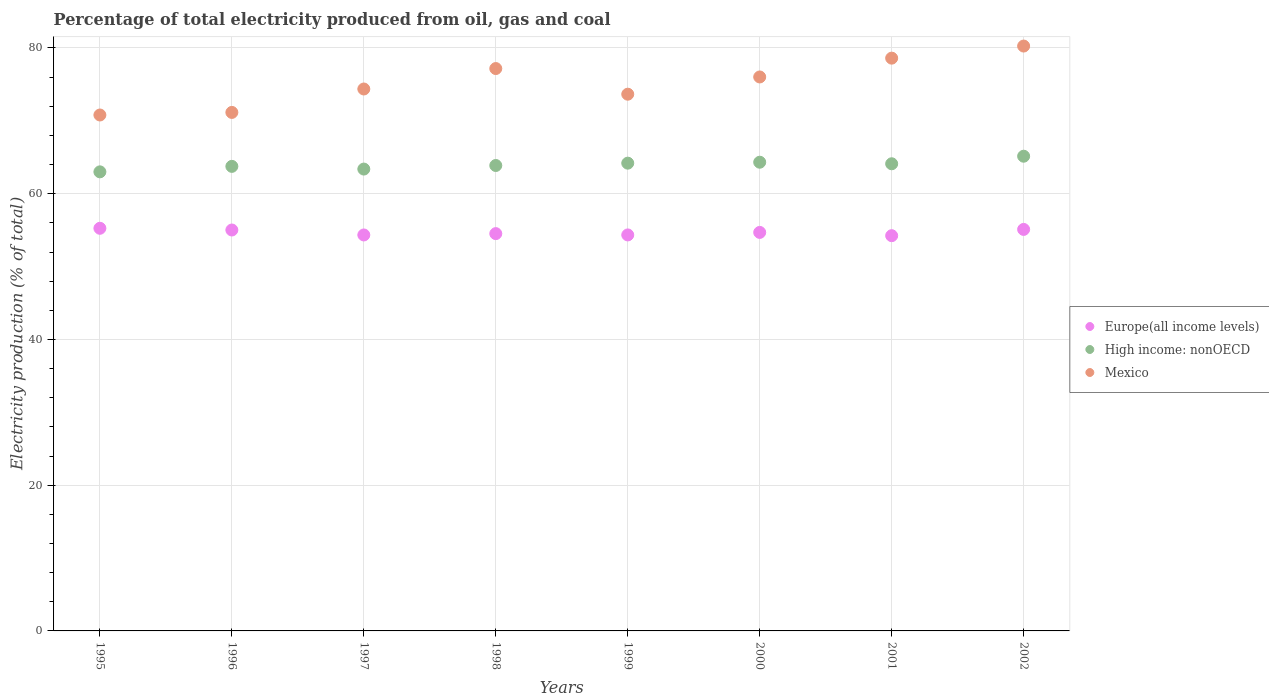How many different coloured dotlines are there?
Keep it short and to the point. 3. What is the electricity production in in Europe(all income levels) in 1995?
Your answer should be very brief. 55.26. Across all years, what is the maximum electricity production in in Europe(all income levels)?
Your answer should be compact. 55.26. Across all years, what is the minimum electricity production in in Mexico?
Your response must be concise. 70.8. In which year was the electricity production in in High income: nonOECD minimum?
Make the answer very short. 1995. What is the total electricity production in in Mexico in the graph?
Your answer should be very brief. 602.07. What is the difference between the electricity production in in Mexico in 1995 and that in 1997?
Offer a terse response. -3.57. What is the difference between the electricity production in in Mexico in 2001 and the electricity production in in High income: nonOECD in 2000?
Make the answer very short. 14.28. What is the average electricity production in in Europe(all income levels) per year?
Keep it short and to the point. 54.69. In the year 2002, what is the difference between the electricity production in in High income: nonOECD and electricity production in in Mexico?
Keep it short and to the point. -15.12. What is the ratio of the electricity production in in Mexico in 1998 to that in 2002?
Offer a very short reply. 0.96. Is the electricity production in in Mexico in 1997 less than that in 1999?
Offer a very short reply. No. What is the difference between the highest and the second highest electricity production in in High income: nonOECD?
Your answer should be very brief. 0.82. What is the difference between the highest and the lowest electricity production in in Mexico?
Offer a very short reply. 9.46. In how many years, is the electricity production in in Mexico greater than the average electricity production in in Mexico taken over all years?
Offer a terse response. 4. Is the sum of the electricity production in in High income: nonOECD in 2000 and 2001 greater than the maximum electricity production in in Mexico across all years?
Your answer should be very brief. Yes. Does the electricity production in in Mexico monotonically increase over the years?
Your response must be concise. No. Is the electricity production in in High income: nonOECD strictly greater than the electricity production in in Europe(all income levels) over the years?
Give a very brief answer. Yes. How many dotlines are there?
Offer a very short reply. 3. How many years are there in the graph?
Provide a succinct answer. 8. What is the difference between two consecutive major ticks on the Y-axis?
Offer a very short reply. 20. Are the values on the major ticks of Y-axis written in scientific E-notation?
Ensure brevity in your answer.  No. Does the graph contain any zero values?
Make the answer very short. No. Does the graph contain grids?
Offer a very short reply. Yes. How are the legend labels stacked?
Give a very brief answer. Vertical. What is the title of the graph?
Keep it short and to the point. Percentage of total electricity produced from oil, gas and coal. Does "Lao PDR" appear as one of the legend labels in the graph?
Offer a terse response. No. What is the label or title of the X-axis?
Ensure brevity in your answer.  Years. What is the label or title of the Y-axis?
Your answer should be compact. Electricity production (% of total). What is the Electricity production (% of total) of Europe(all income levels) in 1995?
Provide a succinct answer. 55.26. What is the Electricity production (% of total) of High income: nonOECD in 1995?
Provide a short and direct response. 63. What is the Electricity production (% of total) of Mexico in 1995?
Give a very brief answer. 70.8. What is the Electricity production (% of total) of Europe(all income levels) in 1996?
Make the answer very short. 55.02. What is the Electricity production (% of total) of High income: nonOECD in 1996?
Make the answer very short. 63.75. What is the Electricity production (% of total) in Mexico in 1996?
Give a very brief answer. 71.16. What is the Electricity production (% of total) in Europe(all income levels) in 1997?
Your answer should be very brief. 54.34. What is the Electricity production (% of total) of High income: nonOECD in 1997?
Your answer should be very brief. 63.38. What is the Electricity production (% of total) in Mexico in 1997?
Offer a very short reply. 74.37. What is the Electricity production (% of total) of Europe(all income levels) in 1998?
Provide a succinct answer. 54.53. What is the Electricity production (% of total) of High income: nonOECD in 1998?
Offer a terse response. 63.87. What is the Electricity production (% of total) of Mexico in 1998?
Give a very brief answer. 77.18. What is the Electricity production (% of total) in Europe(all income levels) in 1999?
Your answer should be compact. 54.34. What is the Electricity production (% of total) in High income: nonOECD in 1999?
Give a very brief answer. 64.2. What is the Electricity production (% of total) in Mexico in 1999?
Provide a succinct answer. 73.66. What is the Electricity production (% of total) of Europe(all income levels) in 2000?
Your response must be concise. 54.69. What is the Electricity production (% of total) of High income: nonOECD in 2000?
Give a very brief answer. 64.32. What is the Electricity production (% of total) of Mexico in 2000?
Offer a very short reply. 76.02. What is the Electricity production (% of total) of Europe(all income levels) in 2001?
Make the answer very short. 54.24. What is the Electricity production (% of total) of High income: nonOECD in 2001?
Your response must be concise. 64.11. What is the Electricity production (% of total) in Mexico in 2001?
Ensure brevity in your answer.  78.61. What is the Electricity production (% of total) of Europe(all income levels) in 2002?
Your answer should be compact. 55.1. What is the Electricity production (% of total) of High income: nonOECD in 2002?
Your response must be concise. 65.15. What is the Electricity production (% of total) in Mexico in 2002?
Provide a succinct answer. 80.27. Across all years, what is the maximum Electricity production (% of total) in Europe(all income levels)?
Offer a terse response. 55.26. Across all years, what is the maximum Electricity production (% of total) in High income: nonOECD?
Offer a very short reply. 65.15. Across all years, what is the maximum Electricity production (% of total) of Mexico?
Give a very brief answer. 80.27. Across all years, what is the minimum Electricity production (% of total) in Europe(all income levels)?
Make the answer very short. 54.24. Across all years, what is the minimum Electricity production (% of total) in High income: nonOECD?
Provide a succinct answer. 63. Across all years, what is the minimum Electricity production (% of total) in Mexico?
Your answer should be compact. 70.8. What is the total Electricity production (% of total) of Europe(all income levels) in the graph?
Your answer should be very brief. 437.52. What is the total Electricity production (% of total) of High income: nonOECD in the graph?
Your response must be concise. 511.79. What is the total Electricity production (% of total) in Mexico in the graph?
Offer a very short reply. 602.07. What is the difference between the Electricity production (% of total) in Europe(all income levels) in 1995 and that in 1996?
Make the answer very short. 0.24. What is the difference between the Electricity production (% of total) of High income: nonOECD in 1995 and that in 1996?
Your response must be concise. -0.75. What is the difference between the Electricity production (% of total) in Mexico in 1995 and that in 1996?
Your answer should be compact. -0.35. What is the difference between the Electricity production (% of total) of Europe(all income levels) in 1995 and that in 1997?
Give a very brief answer. 0.92. What is the difference between the Electricity production (% of total) in High income: nonOECD in 1995 and that in 1997?
Offer a very short reply. -0.38. What is the difference between the Electricity production (% of total) in Mexico in 1995 and that in 1997?
Make the answer very short. -3.57. What is the difference between the Electricity production (% of total) of Europe(all income levels) in 1995 and that in 1998?
Provide a succinct answer. 0.73. What is the difference between the Electricity production (% of total) in High income: nonOECD in 1995 and that in 1998?
Offer a very short reply. -0.87. What is the difference between the Electricity production (% of total) of Mexico in 1995 and that in 1998?
Your response must be concise. -6.37. What is the difference between the Electricity production (% of total) of Europe(all income levels) in 1995 and that in 1999?
Provide a succinct answer. 0.91. What is the difference between the Electricity production (% of total) of High income: nonOECD in 1995 and that in 1999?
Offer a terse response. -1.19. What is the difference between the Electricity production (% of total) in Mexico in 1995 and that in 1999?
Offer a very short reply. -2.85. What is the difference between the Electricity production (% of total) in Europe(all income levels) in 1995 and that in 2000?
Offer a terse response. 0.57. What is the difference between the Electricity production (% of total) in High income: nonOECD in 1995 and that in 2000?
Offer a very short reply. -1.32. What is the difference between the Electricity production (% of total) of Mexico in 1995 and that in 2000?
Your answer should be very brief. -5.22. What is the difference between the Electricity production (% of total) in Europe(all income levels) in 1995 and that in 2001?
Your answer should be compact. 1.02. What is the difference between the Electricity production (% of total) in High income: nonOECD in 1995 and that in 2001?
Keep it short and to the point. -1.11. What is the difference between the Electricity production (% of total) in Mexico in 1995 and that in 2001?
Your answer should be very brief. -7.8. What is the difference between the Electricity production (% of total) in Europe(all income levels) in 1995 and that in 2002?
Provide a succinct answer. 0.15. What is the difference between the Electricity production (% of total) in High income: nonOECD in 1995 and that in 2002?
Give a very brief answer. -2.14. What is the difference between the Electricity production (% of total) in Mexico in 1995 and that in 2002?
Keep it short and to the point. -9.46. What is the difference between the Electricity production (% of total) of Europe(all income levels) in 1996 and that in 1997?
Your answer should be compact. 0.68. What is the difference between the Electricity production (% of total) in High income: nonOECD in 1996 and that in 1997?
Your answer should be compact. 0.37. What is the difference between the Electricity production (% of total) of Mexico in 1996 and that in 1997?
Your answer should be very brief. -3.21. What is the difference between the Electricity production (% of total) of Europe(all income levels) in 1996 and that in 1998?
Your response must be concise. 0.5. What is the difference between the Electricity production (% of total) in High income: nonOECD in 1996 and that in 1998?
Keep it short and to the point. -0.12. What is the difference between the Electricity production (% of total) of Mexico in 1996 and that in 1998?
Keep it short and to the point. -6.02. What is the difference between the Electricity production (% of total) of Europe(all income levels) in 1996 and that in 1999?
Offer a very short reply. 0.68. What is the difference between the Electricity production (% of total) of High income: nonOECD in 1996 and that in 1999?
Your answer should be very brief. -0.44. What is the difference between the Electricity production (% of total) in Mexico in 1996 and that in 1999?
Provide a succinct answer. -2.5. What is the difference between the Electricity production (% of total) in Europe(all income levels) in 1996 and that in 2000?
Your response must be concise. 0.33. What is the difference between the Electricity production (% of total) of High income: nonOECD in 1996 and that in 2000?
Keep it short and to the point. -0.57. What is the difference between the Electricity production (% of total) in Mexico in 1996 and that in 2000?
Give a very brief answer. -4.87. What is the difference between the Electricity production (% of total) of Europe(all income levels) in 1996 and that in 2001?
Your response must be concise. 0.78. What is the difference between the Electricity production (% of total) of High income: nonOECD in 1996 and that in 2001?
Your response must be concise. -0.36. What is the difference between the Electricity production (% of total) in Mexico in 1996 and that in 2001?
Offer a terse response. -7.45. What is the difference between the Electricity production (% of total) in Europe(all income levels) in 1996 and that in 2002?
Your answer should be very brief. -0.08. What is the difference between the Electricity production (% of total) of High income: nonOECD in 1996 and that in 2002?
Provide a succinct answer. -1.39. What is the difference between the Electricity production (% of total) in Mexico in 1996 and that in 2002?
Give a very brief answer. -9.11. What is the difference between the Electricity production (% of total) of Europe(all income levels) in 1997 and that in 1998?
Offer a very short reply. -0.18. What is the difference between the Electricity production (% of total) in High income: nonOECD in 1997 and that in 1998?
Offer a very short reply. -0.49. What is the difference between the Electricity production (% of total) of Mexico in 1997 and that in 1998?
Offer a very short reply. -2.81. What is the difference between the Electricity production (% of total) in Europe(all income levels) in 1997 and that in 1999?
Provide a short and direct response. -0. What is the difference between the Electricity production (% of total) in High income: nonOECD in 1997 and that in 1999?
Provide a succinct answer. -0.81. What is the difference between the Electricity production (% of total) in Mexico in 1997 and that in 1999?
Keep it short and to the point. 0.71. What is the difference between the Electricity production (% of total) of Europe(all income levels) in 1997 and that in 2000?
Give a very brief answer. -0.35. What is the difference between the Electricity production (% of total) of High income: nonOECD in 1997 and that in 2000?
Provide a short and direct response. -0.94. What is the difference between the Electricity production (% of total) in Mexico in 1997 and that in 2000?
Offer a terse response. -1.65. What is the difference between the Electricity production (% of total) of Europe(all income levels) in 1997 and that in 2001?
Ensure brevity in your answer.  0.1. What is the difference between the Electricity production (% of total) in High income: nonOECD in 1997 and that in 2001?
Offer a terse response. -0.73. What is the difference between the Electricity production (% of total) in Mexico in 1997 and that in 2001?
Make the answer very short. -4.23. What is the difference between the Electricity production (% of total) of Europe(all income levels) in 1997 and that in 2002?
Your answer should be very brief. -0.76. What is the difference between the Electricity production (% of total) in High income: nonOECD in 1997 and that in 2002?
Your response must be concise. -1.76. What is the difference between the Electricity production (% of total) of Mexico in 1997 and that in 2002?
Give a very brief answer. -5.89. What is the difference between the Electricity production (% of total) of Europe(all income levels) in 1998 and that in 1999?
Offer a very short reply. 0.18. What is the difference between the Electricity production (% of total) of High income: nonOECD in 1998 and that in 1999?
Offer a very short reply. -0.32. What is the difference between the Electricity production (% of total) in Mexico in 1998 and that in 1999?
Offer a very short reply. 3.52. What is the difference between the Electricity production (% of total) in Europe(all income levels) in 1998 and that in 2000?
Keep it short and to the point. -0.17. What is the difference between the Electricity production (% of total) of High income: nonOECD in 1998 and that in 2000?
Your answer should be very brief. -0.45. What is the difference between the Electricity production (% of total) in Mexico in 1998 and that in 2000?
Give a very brief answer. 1.15. What is the difference between the Electricity production (% of total) in Europe(all income levels) in 1998 and that in 2001?
Make the answer very short. 0.28. What is the difference between the Electricity production (% of total) of High income: nonOECD in 1998 and that in 2001?
Keep it short and to the point. -0.24. What is the difference between the Electricity production (% of total) in Mexico in 1998 and that in 2001?
Offer a terse response. -1.43. What is the difference between the Electricity production (% of total) in Europe(all income levels) in 1998 and that in 2002?
Make the answer very short. -0.58. What is the difference between the Electricity production (% of total) in High income: nonOECD in 1998 and that in 2002?
Your answer should be very brief. -1.27. What is the difference between the Electricity production (% of total) in Mexico in 1998 and that in 2002?
Give a very brief answer. -3.09. What is the difference between the Electricity production (% of total) of Europe(all income levels) in 1999 and that in 2000?
Provide a succinct answer. -0.35. What is the difference between the Electricity production (% of total) of High income: nonOECD in 1999 and that in 2000?
Give a very brief answer. -0.13. What is the difference between the Electricity production (% of total) of Mexico in 1999 and that in 2000?
Provide a short and direct response. -2.37. What is the difference between the Electricity production (% of total) in Europe(all income levels) in 1999 and that in 2001?
Offer a very short reply. 0.1. What is the difference between the Electricity production (% of total) of High income: nonOECD in 1999 and that in 2001?
Offer a very short reply. 0.09. What is the difference between the Electricity production (% of total) of Mexico in 1999 and that in 2001?
Keep it short and to the point. -4.95. What is the difference between the Electricity production (% of total) of Europe(all income levels) in 1999 and that in 2002?
Offer a terse response. -0.76. What is the difference between the Electricity production (% of total) of High income: nonOECD in 1999 and that in 2002?
Offer a very short reply. -0.95. What is the difference between the Electricity production (% of total) in Mexico in 1999 and that in 2002?
Your answer should be very brief. -6.61. What is the difference between the Electricity production (% of total) in Europe(all income levels) in 2000 and that in 2001?
Offer a terse response. 0.45. What is the difference between the Electricity production (% of total) in High income: nonOECD in 2000 and that in 2001?
Offer a very short reply. 0.21. What is the difference between the Electricity production (% of total) in Mexico in 2000 and that in 2001?
Keep it short and to the point. -2.58. What is the difference between the Electricity production (% of total) in Europe(all income levels) in 2000 and that in 2002?
Offer a very short reply. -0.41. What is the difference between the Electricity production (% of total) of High income: nonOECD in 2000 and that in 2002?
Provide a short and direct response. -0.82. What is the difference between the Electricity production (% of total) of Mexico in 2000 and that in 2002?
Ensure brevity in your answer.  -4.24. What is the difference between the Electricity production (% of total) of Europe(all income levels) in 2001 and that in 2002?
Provide a succinct answer. -0.86. What is the difference between the Electricity production (% of total) of High income: nonOECD in 2001 and that in 2002?
Offer a very short reply. -1.04. What is the difference between the Electricity production (% of total) of Mexico in 2001 and that in 2002?
Your response must be concise. -1.66. What is the difference between the Electricity production (% of total) of Europe(all income levels) in 1995 and the Electricity production (% of total) of High income: nonOECD in 1996?
Ensure brevity in your answer.  -8.5. What is the difference between the Electricity production (% of total) in Europe(all income levels) in 1995 and the Electricity production (% of total) in Mexico in 1996?
Ensure brevity in your answer.  -15.9. What is the difference between the Electricity production (% of total) of High income: nonOECD in 1995 and the Electricity production (% of total) of Mexico in 1996?
Keep it short and to the point. -8.16. What is the difference between the Electricity production (% of total) of Europe(all income levels) in 1995 and the Electricity production (% of total) of High income: nonOECD in 1997?
Keep it short and to the point. -8.13. What is the difference between the Electricity production (% of total) in Europe(all income levels) in 1995 and the Electricity production (% of total) in Mexico in 1997?
Your answer should be compact. -19.12. What is the difference between the Electricity production (% of total) in High income: nonOECD in 1995 and the Electricity production (% of total) in Mexico in 1997?
Ensure brevity in your answer.  -11.37. What is the difference between the Electricity production (% of total) in Europe(all income levels) in 1995 and the Electricity production (% of total) in High income: nonOECD in 1998?
Give a very brief answer. -8.62. What is the difference between the Electricity production (% of total) of Europe(all income levels) in 1995 and the Electricity production (% of total) of Mexico in 1998?
Your answer should be very brief. -21.92. What is the difference between the Electricity production (% of total) in High income: nonOECD in 1995 and the Electricity production (% of total) in Mexico in 1998?
Provide a short and direct response. -14.18. What is the difference between the Electricity production (% of total) in Europe(all income levels) in 1995 and the Electricity production (% of total) in High income: nonOECD in 1999?
Give a very brief answer. -8.94. What is the difference between the Electricity production (% of total) of Europe(all income levels) in 1995 and the Electricity production (% of total) of Mexico in 1999?
Offer a terse response. -18.4. What is the difference between the Electricity production (% of total) of High income: nonOECD in 1995 and the Electricity production (% of total) of Mexico in 1999?
Offer a terse response. -10.66. What is the difference between the Electricity production (% of total) in Europe(all income levels) in 1995 and the Electricity production (% of total) in High income: nonOECD in 2000?
Make the answer very short. -9.07. What is the difference between the Electricity production (% of total) in Europe(all income levels) in 1995 and the Electricity production (% of total) in Mexico in 2000?
Offer a terse response. -20.77. What is the difference between the Electricity production (% of total) of High income: nonOECD in 1995 and the Electricity production (% of total) of Mexico in 2000?
Keep it short and to the point. -13.02. What is the difference between the Electricity production (% of total) in Europe(all income levels) in 1995 and the Electricity production (% of total) in High income: nonOECD in 2001?
Give a very brief answer. -8.85. What is the difference between the Electricity production (% of total) in Europe(all income levels) in 1995 and the Electricity production (% of total) in Mexico in 2001?
Provide a succinct answer. -23.35. What is the difference between the Electricity production (% of total) of High income: nonOECD in 1995 and the Electricity production (% of total) of Mexico in 2001?
Give a very brief answer. -15.6. What is the difference between the Electricity production (% of total) in Europe(all income levels) in 1995 and the Electricity production (% of total) in High income: nonOECD in 2002?
Make the answer very short. -9.89. What is the difference between the Electricity production (% of total) of Europe(all income levels) in 1995 and the Electricity production (% of total) of Mexico in 2002?
Offer a terse response. -25.01. What is the difference between the Electricity production (% of total) of High income: nonOECD in 1995 and the Electricity production (% of total) of Mexico in 2002?
Provide a short and direct response. -17.26. What is the difference between the Electricity production (% of total) of Europe(all income levels) in 1996 and the Electricity production (% of total) of High income: nonOECD in 1997?
Provide a short and direct response. -8.36. What is the difference between the Electricity production (% of total) of Europe(all income levels) in 1996 and the Electricity production (% of total) of Mexico in 1997?
Ensure brevity in your answer.  -19.35. What is the difference between the Electricity production (% of total) in High income: nonOECD in 1996 and the Electricity production (% of total) in Mexico in 1997?
Give a very brief answer. -10.62. What is the difference between the Electricity production (% of total) of Europe(all income levels) in 1996 and the Electricity production (% of total) of High income: nonOECD in 1998?
Offer a terse response. -8.85. What is the difference between the Electricity production (% of total) in Europe(all income levels) in 1996 and the Electricity production (% of total) in Mexico in 1998?
Give a very brief answer. -22.16. What is the difference between the Electricity production (% of total) in High income: nonOECD in 1996 and the Electricity production (% of total) in Mexico in 1998?
Your response must be concise. -13.43. What is the difference between the Electricity production (% of total) in Europe(all income levels) in 1996 and the Electricity production (% of total) in High income: nonOECD in 1999?
Provide a succinct answer. -9.17. What is the difference between the Electricity production (% of total) in Europe(all income levels) in 1996 and the Electricity production (% of total) in Mexico in 1999?
Offer a very short reply. -18.64. What is the difference between the Electricity production (% of total) in High income: nonOECD in 1996 and the Electricity production (% of total) in Mexico in 1999?
Offer a terse response. -9.9. What is the difference between the Electricity production (% of total) in Europe(all income levels) in 1996 and the Electricity production (% of total) in High income: nonOECD in 2000?
Keep it short and to the point. -9.3. What is the difference between the Electricity production (% of total) of Europe(all income levels) in 1996 and the Electricity production (% of total) of Mexico in 2000?
Make the answer very short. -21. What is the difference between the Electricity production (% of total) of High income: nonOECD in 1996 and the Electricity production (% of total) of Mexico in 2000?
Your answer should be very brief. -12.27. What is the difference between the Electricity production (% of total) in Europe(all income levels) in 1996 and the Electricity production (% of total) in High income: nonOECD in 2001?
Offer a very short reply. -9.09. What is the difference between the Electricity production (% of total) in Europe(all income levels) in 1996 and the Electricity production (% of total) in Mexico in 2001?
Keep it short and to the point. -23.59. What is the difference between the Electricity production (% of total) of High income: nonOECD in 1996 and the Electricity production (% of total) of Mexico in 2001?
Keep it short and to the point. -14.85. What is the difference between the Electricity production (% of total) of Europe(all income levels) in 1996 and the Electricity production (% of total) of High income: nonOECD in 2002?
Keep it short and to the point. -10.13. What is the difference between the Electricity production (% of total) of Europe(all income levels) in 1996 and the Electricity production (% of total) of Mexico in 2002?
Your answer should be compact. -25.24. What is the difference between the Electricity production (% of total) in High income: nonOECD in 1996 and the Electricity production (% of total) in Mexico in 2002?
Your response must be concise. -16.51. What is the difference between the Electricity production (% of total) of Europe(all income levels) in 1997 and the Electricity production (% of total) of High income: nonOECD in 1998?
Provide a succinct answer. -9.53. What is the difference between the Electricity production (% of total) in Europe(all income levels) in 1997 and the Electricity production (% of total) in Mexico in 1998?
Keep it short and to the point. -22.84. What is the difference between the Electricity production (% of total) of High income: nonOECD in 1997 and the Electricity production (% of total) of Mexico in 1998?
Ensure brevity in your answer.  -13.8. What is the difference between the Electricity production (% of total) in Europe(all income levels) in 1997 and the Electricity production (% of total) in High income: nonOECD in 1999?
Offer a terse response. -9.85. What is the difference between the Electricity production (% of total) in Europe(all income levels) in 1997 and the Electricity production (% of total) in Mexico in 1999?
Ensure brevity in your answer.  -19.32. What is the difference between the Electricity production (% of total) of High income: nonOECD in 1997 and the Electricity production (% of total) of Mexico in 1999?
Offer a very short reply. -10.28. What is the difference between the Electricity production (% of total) in Europe(all income levels) in 1997 and the Electricity production (% of total) in High income: nonOECD in 2000?
Offer a terse response. -9.98. What is the difference between the Electricity production (% of total) in Europe(all income levels) in 1997 and the Electricity production (% of total) in Mexico in 2000?
Make the answer very short. -21.68. What is the difference between the Electricity production (% of total) in High income: nonOECD in 1997 and the Electricity production (% of total) in Mexico in 2000?
Your response must be concise. -12.64. What is the difference between the Electricity production (% of total) of Europe(all income levels) in 1997 and the Electricity production (% of total) of High income: nonOECD in 2001?
Offer a very short reply. -9.77. What is the difference between the Electricity production (% of total) in Europe(all income levels) in 1997 and the Electricity production (% of total) in Mexico in 2001?
Ensure brevity in your answer.  -24.27. What is the difference between the Electricity production (% of total) in High income: nonOECD in 1997 and the Electricity production (% of total) in Mexico in 2001?
Your answer should be very brief. -15.22. What is the difference between the Electricity production (% of total) in Europe(all income levels) in 1997 and the Electricity production (% of total) in High income: nonOECD in 2002?
Offer a very short reply. -10.81. What is the difference between the Electricity production (% of total) of Europe(all income levels) in 1997 and the Electricity production (% of total) of Mexico in 2002?
Provide a succinct answer. -25.92. What is the difference between the Electricity production (% of total) of High income: nonOECD in 1997 and the Electricity production (% of total) of Mexico in 2002?
Ensure brevity in your answer.  -16.88. What is the difference between the Electricity production (% of total) of Europe(all income levels) in 1998 and the Electricity production (% of total) of High income: nonOECD in 1999?
Make the answer very short. -9.67. What is the difference between the Electricity production (% of total) of Europe(all income levels) in 1998 and the Electricity production (% of total) of Mexico in 1999?
Your response must be concise. -19.13. What is the difference between the Electricity production (% of total) of High income: nonOECD in 1998 and the Electricity production (% of total) of Mexico in 1999?
Offer a very short reply. -9.78. What is the difference between the Electricity production (% of total) in Europe(all income levels) in 1998 and the Electricity production (% of total) in High income: nonOECD in 2000?
Provide a short and direct response. -9.8. What is the difference between the Electricity production (% of total) of Europe(all income levels) in 1998 and the Electricity production (% of total) of Mexico in 2000?
Offer a very short reply. -21.5. What is the difference between the Electricity production (% of total) of High income: nonOECD in 1998 and the Electricity production (% of total) of Mexico in 2000?
Provide a succinct answer. -12.15. What is the difference between the Electricity production (% of total) in Europe(all income levels) in 1998 and the Electricity production (% of total) in High income: nonOECD in 2001?
Keep it short and to the point. -9.59. What is the difference between the Electricity production (% of total) in Europe(all income levels) in 1998 and the Electricity production (% of total) in Mexico in 2001?
Your response must be concise. -24.08. What is the difference between the Electricity production (% of total) in High income: nonOECD in 1998 and the Electricity production (% of total) in Mexico in 2001?
Give a very brief answer. -14.73. What is the difference between the Electricity production (% of total) of Europe(all income levels) in 1998 and the Electricity production (% of total) of High income: nonOECD in 2002?
Make the answer very short. -10.62. What is the difference between the Electricity production (% of total) of Europe(all income levels) in 1998 and the Electricity production (% of total) of Mexico in 2002?
Offer a terse response. -25.74. What is the difference between the Electricity production (% of total) in High income: nonOECD in 1998 and the Electricity production (% of total) in Mexico in 2002?
Offer a terse response. -16.39. What is the difference between the Electricity production (% of total) in Europe(all income levels) in 1999 and the Electricity production (% of total) in High income: nonOECD in 2000?
Keep it short and to the point. -9.98. What is the difference between the Electricity production (% of total) in Europe(all income levels) in 1999 and the Electricity production (% of total) in Mexico in 2000?
Offer a terse response. -21.68. What is the difference between the Electricity production (% of total) in High income: nonOECD in 1999 and the Electricity production (% of total) in Mexico in 2000?
Your response must be concise. -11.83. What is the difference between the Electricity production (% of total) of Europe(all income levels) in 1999 and the Electricity production (% of total) of High income: nonOECD in 2001?
Your response must be concise. -9.77. What is the difference between the Electricity production (% of total) of Europe(all income levels) in 1999 and the Electricity production (% of total) of Mexico in 2001?
Offer a very short reply. -24.26. What is the difference between the Electricity production (% of total) in High income: nonOECD in 1999 and the Electricity production (% of total) in Mexico in 2001?
Ensure brevity in your answer.  -14.41. What is the difference between the Electricity production (% of total) in Europe(all income levels) in 1999 and the Electricity production (% of total) in High income: nonOECD in 2002?
Provide a short and direct response. -10.8. What is the difference between the Electricity production (% of total) in Europe(all income levels) in 1999 and the Electricity production (% of total) in Mexico in 2002?
Ensure brevity in your answer.  -25.92. What is the difference between the Electricity production (% of total) in High income: nonOECD in 1999 and the Electricity production (% of total) in Mexico in 2002?
Offer a very short reply. -16.07. What is the difference between the Electricity production (% of total) of Europe(all income levels) in 2000 and the Electricity production (% of total) of High income: nonOECD in 2001?
Offer a very short reply. -9.42. What is the difference between the Electricity production (% of total) in Europe(all income levels) in 2000 and the Electricity production (% of total) in Mexico in 2001?
Provide a short and direct response. -23.92. What is the difference between the Electricity production (% of total) in High income: nonOECD in 2000 and the Electricity production (% of total) in Mexico in 2001?
Offer a very short reply. -14.28. What is the difference between the Electricity production (% of total) of Europe(all income levels) in 2000 and the Electricity production (% of total) of High income: nonOECD in 2002?
Offer a very short reply. -10.46. What is the difference between the Electricity production (% of total) in Europe(all income levels) in 2000 and the Electricity production (% of total) in Mexico in 2002?
Your answer should be compact. -25.57. What is the difference between the Electricity production (% of total) of High income: nonOECD in 2000 and the Electricity production (% of total) of Mexico in 2002?
Offer a terse response. -15.94. What is the difference between the Electricity production (% of total) in Europe(all income levels) in 2001 and the Electricity production (% of total) in High income: nonOECD in 2002?
Your answer should be compact. -10.91. What is the difference between the Electricity production (% of total) in Europe(all income levels) in 2001 and the Electricity production (% of total) in Mexico in 2002?
Offer a very short reply. -26.02. What is the difference between the Electricity production (% of total) in High income: nonOECD in 2001 and the Electricity production (% of total) in Mexico in 2002?
Your answer should be compact. -16.16. What is the average Electricity production (% of total) in Europe(all income levels) per year?
Your answer should be compact. 54.69. What is the average Electricity production (% of total) of High income: nonOECD per year?
Keep it short and to the point. 63.97. What is the average Electricity production (% of total) of Mexico per year?
Provide a short and direct response. 75.26. In the year 1995, what is the difference between the Electricity production (% of total) of Europe(all income levels) and Electricity production (% of total) of High income: nonOECD?
Ensure brevity in your answer.  -7.75. In the year 1995, what is the difference between the Electricity production (% of total) in Europe(all income levels) and Electricity production (% of total) in Mexico?
Give a very brief answer. -15.55. In the year 1995, what is the difference between the Electricity production (% of total) in High income: nonOECD and Electricity production (% of total) in Mexico?
Ensure brevity in your answer.  -7.8. In the year 1996, what is the difference between the Electricity production (% of total) of Europe(all income levels) and Electricity production (% of total) of High income: nonOECD?
Ensure brevity in your answer.  -8.73. In the year 1996, what is the difference between the Electricity production (% of total) in Europe(all income levels) and Electricity production (% of total) in Mexico?
Your answer should be very brief. -16.14. In the year 1996, what is the difference between the Electricity production (% of total) of High income: nonOECD and Electricity production (% of total) of Mexico?
Your answer should be very brief. -7.4. In the year 1997, what is the difference between the Electricity production (% of total) of Europe(all income levels) and Electricity production (% of total) of High income: nonOECD?
Make the answer very short. -9.04. In the year 1997, what is the difference between the Electricity production (% of total) of Europe(all income levels) and Electricity production (% of total) of Mexico?
Provide a succinct answer. -20.03. In the year 1997, what is the difference between the Electricity production (% of total) in High income: nonOECD and Electricity production (% of total) in Mexico?
Offer a very short reply. -10.99. In the year 1998, what is the difference between the Electricity production (% of total) in Europe(all income levels) and Electricity production (% of total) in High income: nonOECD?
Offer a terse response. -9.35. In the year 1998, what is the difference between the Electricity production (% of total) of Europe(all income levels) and Electricity production (% of total) of Mexico?
Offer a terse response. -22.65. In the year 1998, what is the difference between the Electricity production (% of total) in High income: nonOECD and Electricity production (% of total) in Mexico?
Ensure brevity in your answer.  -13.3. In the year 1999, what is the difference between the Electricity production (% of total) of Europe(all income levels) and Electricity production (% of total) of High income: nonOECD?
Your response must be concise. -9.85. In the year 1999, what is the difference between the Electricity production (% of total) in Europe(all income levels) and Electricity production (% of total) in Mexico?
Offer a very short reply. -19.31. In the year 1999, what is the difference between the Electricity production (% of total) in High income: nonOECD and Electricity production (% of total) in Mexico?
Offer a terse response. -9.46. In the year 2000, what is the difference between the Electricity production (% of total) of Europe(all income levels) and Electricity production (% of total) of High income: nonOECD?
Give a very brief answer. -9.63. In the year 2000, what is the difference between the Electricity production (% of total) in Europe(all income levels) and Electricity production (% of total) in Mexico?
Ensure brevity in your answer.  -21.33. In the year 2000, what is the difference between the Electricity production (% of total) in High income: nonOECD and Electricity production (% of total) in Mexico?
Give a very brief answer. -11.7. In the year 2001, what is the difference between the Electricity production (% of total) of Europe(all income levels) and Electricity production (% of total) of High income: nonOECD?
Ensure brevity in your answer.  -9.87. In the year 2001, what is the difference between the Electricity production (% of total) of Europe(all income levels) and Electricity production (% of total) of Mexico?
Offer a very short reply. -24.37. In the year 2001, what is the difference between the Electricity production (% of total) in High income: nonOECD and Electricity production (% of total) in Mexico?
Your answer should be compact. -14.5. In the year 2002, what is the difference between the Electricity production (% of total) of Europe(all income levels) and Electricity production (% of total) of High income: nonOECD?
Keep it short and to the point. -10.05. In the year 2002, what is the difference between the Electricity production (% of total) in Europe(all income levels) and Electricity production (% of total) in Mexico?
Offer a terse response. -25.16. In the year 2002, what is the difference between the Electricity production (% of total) of High income: nonOECD and Electricity production (% of total) of Mexico?
Your answer should be very brief. -15.12. What is the ratio of the Electricity production (% of total) of Mexico in 1995 to that in 1996?
Ensure brevity in your answer.  0.99. What is the ratio of the Electricity production (% of total) of Europe(all income levels) in 1995 to that in 1997?
Your answer should be compact. 1.02. What is the ratio of the Electricity production (% of total) in Mexico in 1995 to that in 1997?
Offer a very short reply. 0.95. What is the ratio of the Electricity production (% of total) in Europe(all income levels) in 1995 to that in 1998?
Keep it short and to the point. 1.01. What is the ratio of the Electricity production (% of total) of High income: nonOECD in 1995 to that in 1998?
Give a very brief answer. 0.99. What is the ratio of the Electricity production (% of total) in Mexico in 1995 to that in 1998?
Offer a very short reply. 0.92. What is the ratio of the Electricity production (% of total) of Europe(all income levels) in 1995 to that in 1999?
Your answer should be very brief. 1.02. What is the ratio of the Electricity production (% of total) of High income: nonOECD in 1995 to that in 1999?
Make the answer very short. 0.98. What is the ratio of the Electricity production (% of total) in Mexico in 1995 to that in 1999?
Your answer should be very brief. 0.96. What is the ratio of the Electricity production (% of total) of Europe(all income levels) in 1995 to that in 2000?
Your answer should be very brief. 1.01. What is the ratio of the Electricity production (% of total) of High income: nonOECD in 1995 to that in 2000?
Provide a succinct answer. 0.98. What is the ratio of the Electricity production (% of total) in Mexico in 1995 to that in 2000?
Offer a terse response. 0.93. What is the ratio of the Electricity production (% of total) of Europe(all income levels) in 1995 to that in 2001?
Ensure brevity in your answer.  1.02. What is the ratio of the Electricity production (% of total) in High income: nonOECD in 1995 to that in 2001?
Provide a succinct answer. 0.98. What is the ratio of the Electricity production (% of total) in Mexico in 1995 to that in 2001?
Make the answer very short. 0.9. What is the ratio of the Electricity production (% of total) of High income: nonOECD in 1995 to that in 2002?
Ensure brevity in your answer.  0.97. What is the ratio of the Electricity production (% of total) in Mexico in 1995 to that in 2002?
Give a very brief answer. 0.88. What is the ratio of the Electricity production (% of total) of Europe(all income levels) in 1996 to that in 1997?
Offer a very short reply. 1.01. What is the ratio of the Electricity production (% of total) in High income: nonOECD in 1996 to that in 1997?
Keep it short and to the point. 1.01. What is the ratio of the Electricity production (% of total) in Mexico in 1996 to that in 1997?
Your answer should be compact. 0.96. What is the ratio of the Electricity production (% of total) of Europe(all income levels) in 1996 to that in 1998?
Your answer should be compact. 1.01. What is the ratio of the Electricity production (% of total) in High income: nonOECD in 1996 to that in 1998?
Keep it short and to the point. 1. What is the ratio of the Electricity production (% of total) in Mexico in 1996 to that in 1998?
Provide a short and direct response. 0.92. What is the ratio of the Electricity production (% of total) in Europe(all income levels) in 1996 to that in 1999?
Your response must be concise. 1.01. What is the ratio of the Electricity production (% of total) of Mexico in 1996 to that in 1999?
Your response must be concise. 0.97. What is the ratio of the Electricity production (% of total) in Europe(all income levels) in 1996 to that in 2000?
Offer a very short reply. 1.01. What is the ratio of the Electricity production (% of total) in High income: nonOECD in 1996 to that in 2000?
Provide a short and direct response. 0.99. What is the ratio of the Electricity production (% of total) in Mexico in 1996 to that in 2000?
Make the answer very short. 0.94. What is the ratio of the Electricity production (% of total) of Europe(all income levels) in 1996 to that in 2001?
Keep it short and to the point. 1.01. What is the ratio of the Electricity production (% of total) of High income: nonOECD in 1996 to that in 2001?
Make the answer very short. 0.99. What is the ratio of the Electricity production (% of total) of Mexico in 1996 to that in 2001?
Ensure brevity in your answer.  0.91. What is the ratio of the Electricity production (% of total) of High income: nonOECD in 1996 to that in 2002?
Provide a succinct answer. 0.98. What is the ratio of the Electricity production (% of total) of Mexico in 1996 to that in 2002?
Provide a short and direct response. 0.89. What is the ratio of the Electricity production (% of total) of Europe(all income levels) in 1997 to that in 1998?
Give a very brief answer. 1. What is the ratio of the Electricity production (% of total) of Mexico in 1997 to that in 1998?
Offer a terse response. 0.96. What is the ratio of the Electricity production (% of total) in High income: nonOECD in 1997 to that in 1999?
Offer a very short reply. 0.99. What is the ratio of the Electricity production (% of total) in Mexico in 1997 to that in 1999?
Your answer should be compact. 1.01. What is the ratio of the Electricity production (% of total) in High income: nonOECD in 1997 to that in 2000?
Your response must be concise. 0.99. What is the ratio of the Electricity production (% of total) of Mexico in 1997 to that in 2000?
Provide a succinct answer. 0.98. What is the ratio of the Electricity production (% of total) of High income: nonOECD in 1997 to that in 2001?
Your answer should be compact. 0.99. What is the ratio of the Electricity production (% of total) of Mexico in 1997 to that in 2001?
Your answer should be compact. 0.95. What is the ratio of the Electricity production (% of total) of Europe(all income levels) in 1997 to that in 2002?
Ensure brevity in your answer.  0.99. What is the ratio of the Electricity production (% of total) in High income: nonOECD in 1997 to that in 2002?
Make the answer very short. 0.97. What is the ratio of the Electricity production (% of total) of Mexico in 1997 to that in 2002?
Ensure brevity in your answer.  0.93. What is the ratio of the Electricity production (% of total) of Mexico in 1998 to that in 1999?
Offer a very short reply. 1.05. What is the ratio of the Electricity production (% of total) in Mexico in 1998 to that in 2000?
Your response must be concise. 1.02. What is the ratio of the Electricity production (% of total) of High income: nonOECD in 1998 to that in 2001?
Provide a succinct answer. 1. What is the ratio of the Electricity production (% of total) in Mexico in 1998 to that in 2001?
Your answer should be very brief. 0.98. What is the ratio of the Electricity production (% of total) in Europe(all income levels) in 1998 to that in 2002?
Provide a succinct answer. 0.99. What is the ratio of the Electricity production (% of total) in High income: nonOECD in 1998 to that in 2002?
Make the answer very short. 0.98. What is the ratio of the Electricity production (% of total) in Mexico in 1998 to that in 2002?
Ensure brevity in your answer.  0.96. What is the ratio of the Electricity production (% of total) in Europe(all income levels) in 1999 to that in 2000?
Provide a succinct answer. 0.99. What is the ratio of the Electricity production (% of total) of High income: nonOECD in 1999 to that in 2000?
Make the answer very short. 1. What is the ratio of the Electricity production (% of total) of Mexico in 1999 to that in 2000?
Ensure brevity in your answer.  0.97. What is the ratio of the Electricity production (% of total) in High income: nonOECD in 1999 to that in 2001?
Provide a succinct answer. 1. What is the ratio of the Electricity production (% of total) of Mexico in 1999 to that in 2001?
Provide a short and direct response. 0.94. What is the ratio of the Electricity production (% of total) of Europe(all income levels) in 1999 to that in 2002?
Ensure brevity in your answer.  0.99. What is the ratio of the Electricity production (% of total) in High income: nonOECD in 1999 to that in 2002?
Provide a succinct answer. 0.99. What is the ratio of the Electricity production (% of total) in Mexico in 1999 to that in 2002?
Your answer should be compact. 0.92. What is the ratio of the Electricity production (% of total) in Europe(all income levels) in 2000 to that in 2001?
Make the answer very short. 1.01. What is the ratio of the Electricity production (% of total) in Mexico in 2000 to that in 2001?
Your response must be concise. 0.97. What is the ratio of the Electricity production (% of total) of High income: nonOECD in 2000 to that in 2002?
Provide a short and direct response. 0.99. What is the ratio of the Electricity production (% of total) of Mexico in 2000 to that in 2002?
Your answer should be very brief. 0.95. What is the ratio of the Electricity production (% of total) of Europe(all income levels) in 2001 to that in 2002?
Provide a succinct answer. 0.98. What is the ratio of the Electricity production (% of total) of High income: nonOECD in 2001 to that in 2002?
Your answer should be very brief. 0.98. What is the ratio of the Electricity production (% of total) of Mexico in 2001 to that in 2002?
Give a very brief answer. 0.98. What is the difference between the highest and the second highest Electricity production (% of total) in Europe(all income levels)?
Provide a short and direct response. 0.15. What is the difference between the highest and the second highest Electricity production (% of total) in High income: nonOECD?
Offer a terse response. 0.82. What is the difference between the highest and the second highest Electricity production (% of total) in Mexico?
Give a very brief answer. 1.66. What is the difference between the highest and the lowest Electricity production (% of total) in Europe(all income levels)?
Provide a succinct answer. 1.02. What is the difference between the highest and the lowest Electricity production (% of total) in High income: nonOECD?
Ensure brevity in your answer.  2.14. What is the difference between the highest and the lowest Electricity production (% of total) in Mexico?
Give a very brief answer. 9.46. 